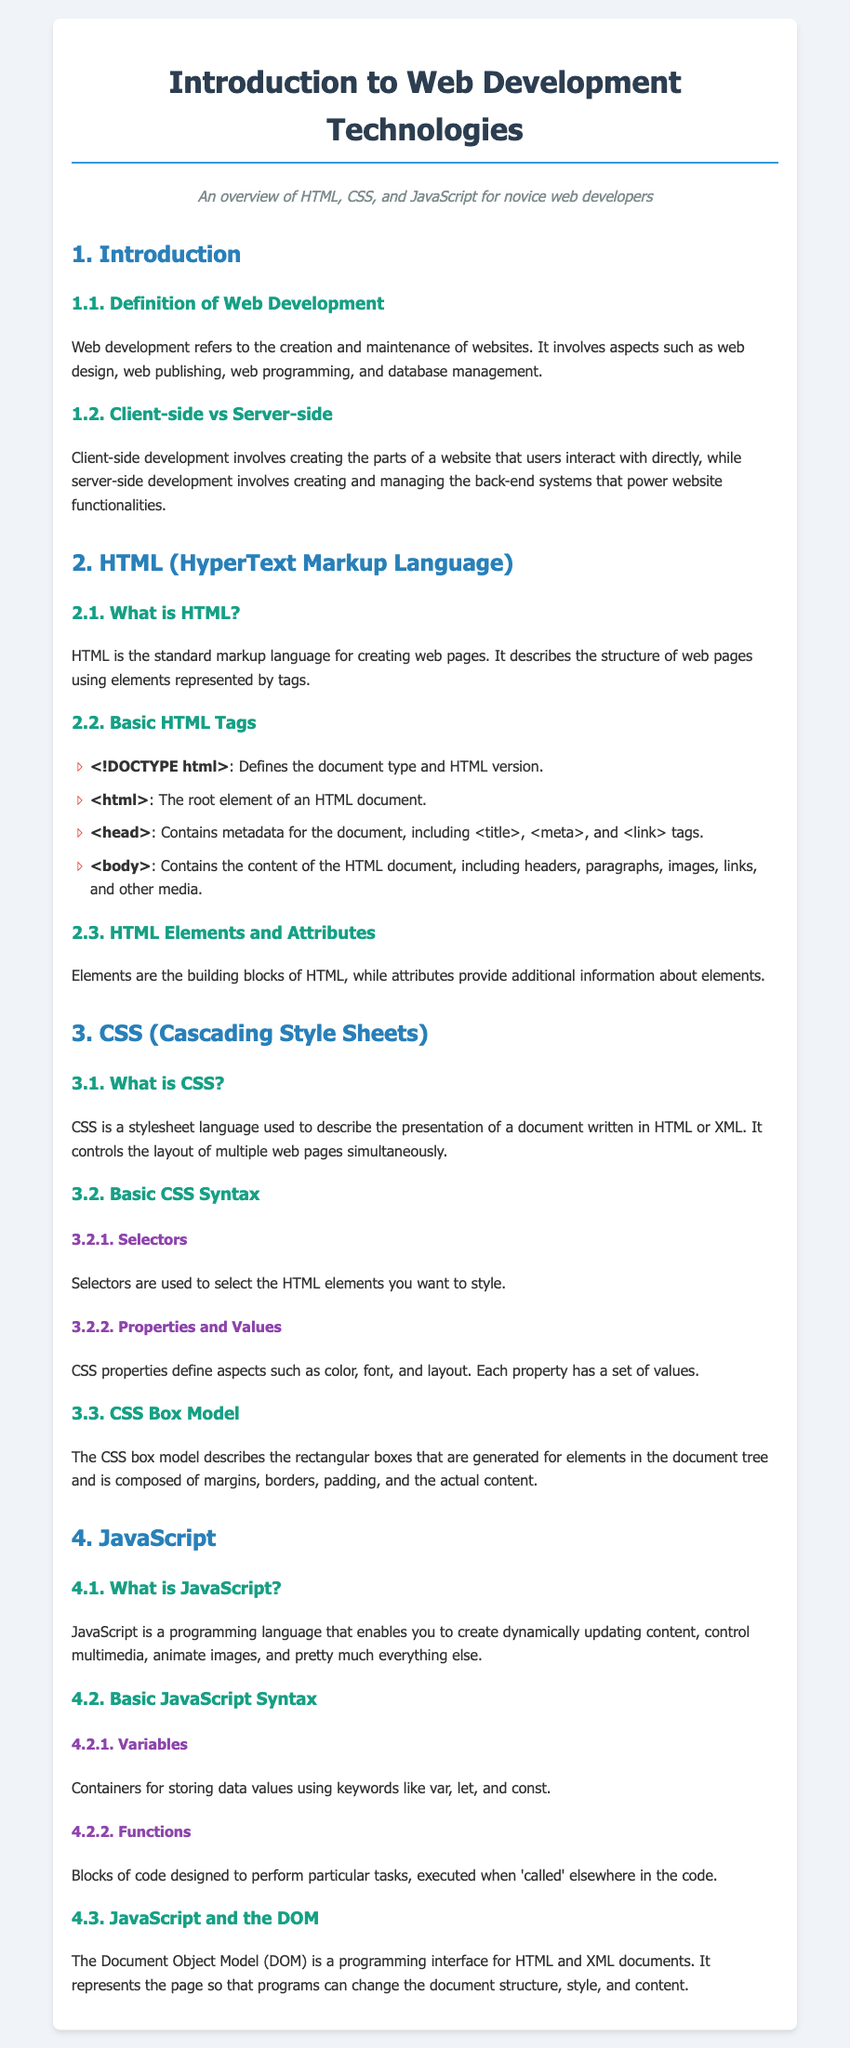What is web development? Web development refers to the creation and maintenance of websites, which involves design, publishing, programming, and database management.
Answer: Creation and maintenance of websites What does client-side development involve? Client-side development involves creating the parts of a website that users interact with directly.
Answer: User interaction What is HTML? HTML is the standard markup language for creating web pages and describes the structure of web pages using elements represented by tags.
Answer: Standard markup language Which tag defines the document type and HTML version? The tag that defines the document type and HTML version is the doctype tag.
Answer: Doctype tag What does CSS stand for? CSS stands for Cascading Style Sheets.
Answer: Cascading Style Sheets What are selectors used for in CSS? Selectors are used to select the HTML elements you want to style.
Answer: Select HTML elements What is the CSS box model? The CSS box model describes the rectangular boxes generated for elements and is composed of margins, borders, padding, and actual content.
Answer: Rectangular boxes What can JavaScript create? JavaScript can create dynamically updating content, control multimedia, animate images, and more.
Answer: Dynamically updating content What does the Document Object Model represent? The Document Object Model represents the page so that programs can change the document structure, style, and content.
Answer: Page representation What keywords are used for variables in JavaScript? Keywords used for variables in JavaScript include var, let, and const.
Answer: Var, let, const 